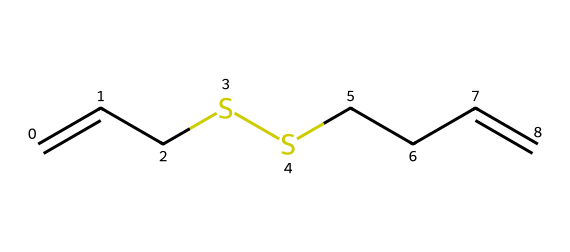How many carbon atoms are present in diallyl disulfide? The SMILES representation shows "C=CC" and "CCC", which indicates there are 6 carbon atoms in total.
Answer: 6 What functional groups are present in this compound? The SMILES notation indicates the presence of "SS" representing disulfide, which is the main functional group in this compound.
Answer: disulfide How many double bonds are in diallyl disulfide? The "C=C" part in the SMILES string indicates there are 2 double bonds present in the structure.
Answer: 2 What contributes to the characteristic flavor of this compound? The disulfide group is known for its pungent aroma and flavor, contributing distinct properties in food, particularly in onions.
Answer: disulfide group Which type of chemical compound is diallyl disulfide classified as? Given it contains carbon and sulfur and is centered around the disulfide functional group, it falls under the category of organosulfur compounds.
Answer: organosulfur compound How does the linear structure of diallyl disulfide aid in its function? The structure allows rotational flexibility around the single C–C bonds, enhancing its ability to interact with other molecules, which is crucial for its flavor characteristics.
Answer: interacts better What is the molecular formula derived from the SMILES representation? The count of carbon (C), hydrogen (H), and sulfur (S) atoms makes the molecular formula C6H10S2 when analyzed based on the SMILES.
Answer: C6H10S2 